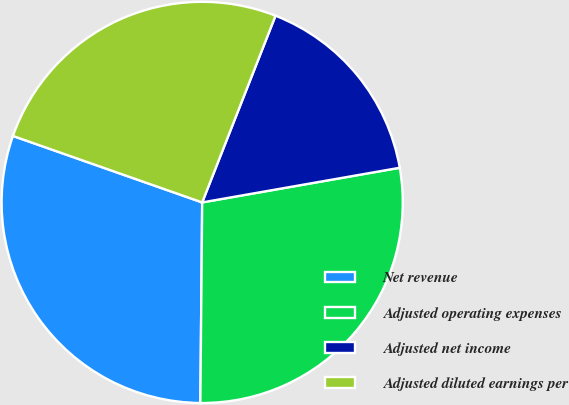Convert chart to OTSL. <chart><loc_0><loc_0><loc_500><loc_500><pie_chart><fcel>Net revenue<fcel>Adjusted operating expenses<fcel>Adjusted net income<fcel>Adjusted diluted earnings per<nl><fcel>30.23%<fcel>27.91%<fcel>16.28%<fcel>25.58%<nl></chart> 